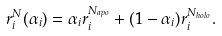Convert formula to latex. <formula><loc_0><loc_0><loc_500><loc_500>r _ { i } ^ { N } ( \alpha _ { i } ) = \alpha _ { i } r _ { i } ^ { N _ { a p o } } + ( 1 - \alpha _ { i } ) r _ { i } ^ { N _ { h o l o } } .</formula> 